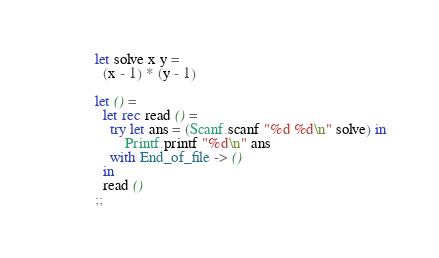<code> <loc_0><loc_0><loc_500><loc_500><_OCaml_>let solve x y = 
  (x - 1) * (y - 1)

let () =
  let rec read () =
    try let ans = (Scanf.scanf "%d %d\n" solve) in
        Printf.printf "%d\n" ans
    with End_of_file -> ()
  in
  read ()
;;
</code> 